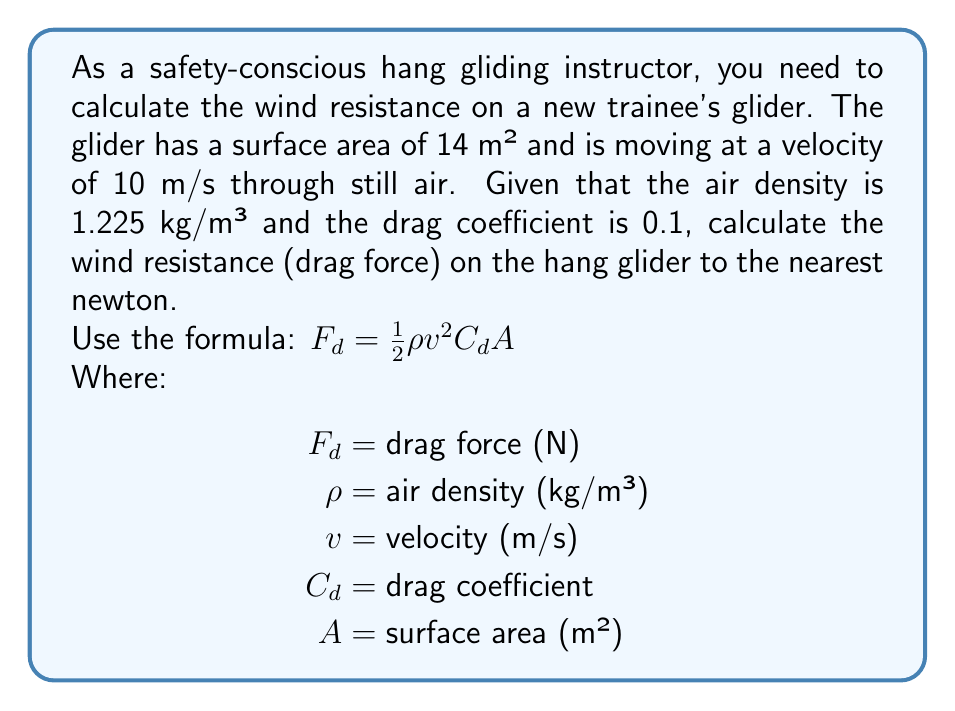Solve this math problem. Let's approach this step-by-step:

1) We're given:
   $\rho = 1.225$ kg/m³
   $v = 10$ m/s
   $C_d = 0.1$
   $A = 14$ m²

2) We'll use the formula: $F_d = \frac{1}{2} \rho v^2 C_d A$

3) Let's substitute our values:
   $F_d = \frac{1}{2} \cdot 1.225 \cdot 10^2 \cdot 0.1 \cdot 14$

4) Calculate $v^2$:
   $F_d = \frac{1}{2} \cdot 1.225 \cdot 100 \cdot 0.1 \cdot 14$

5) Multiply the numbers:
   $F_d = 0.5 \cdot 1.225 \cdot 100 \cdot 0.1 \cdot 14$
   $F_d = 85.75$ N

6) Rounding to the nearest newton:
   $F_d \approx 86$ N

Therefore, the wind resistance (drag force) on the hang glider is approximately 86 newtons.
Answer: 86 N 